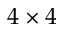Convert formula to latex. <formula><loc_0><loc_0><loc_500><loc_500>4 \times 4</formula> 